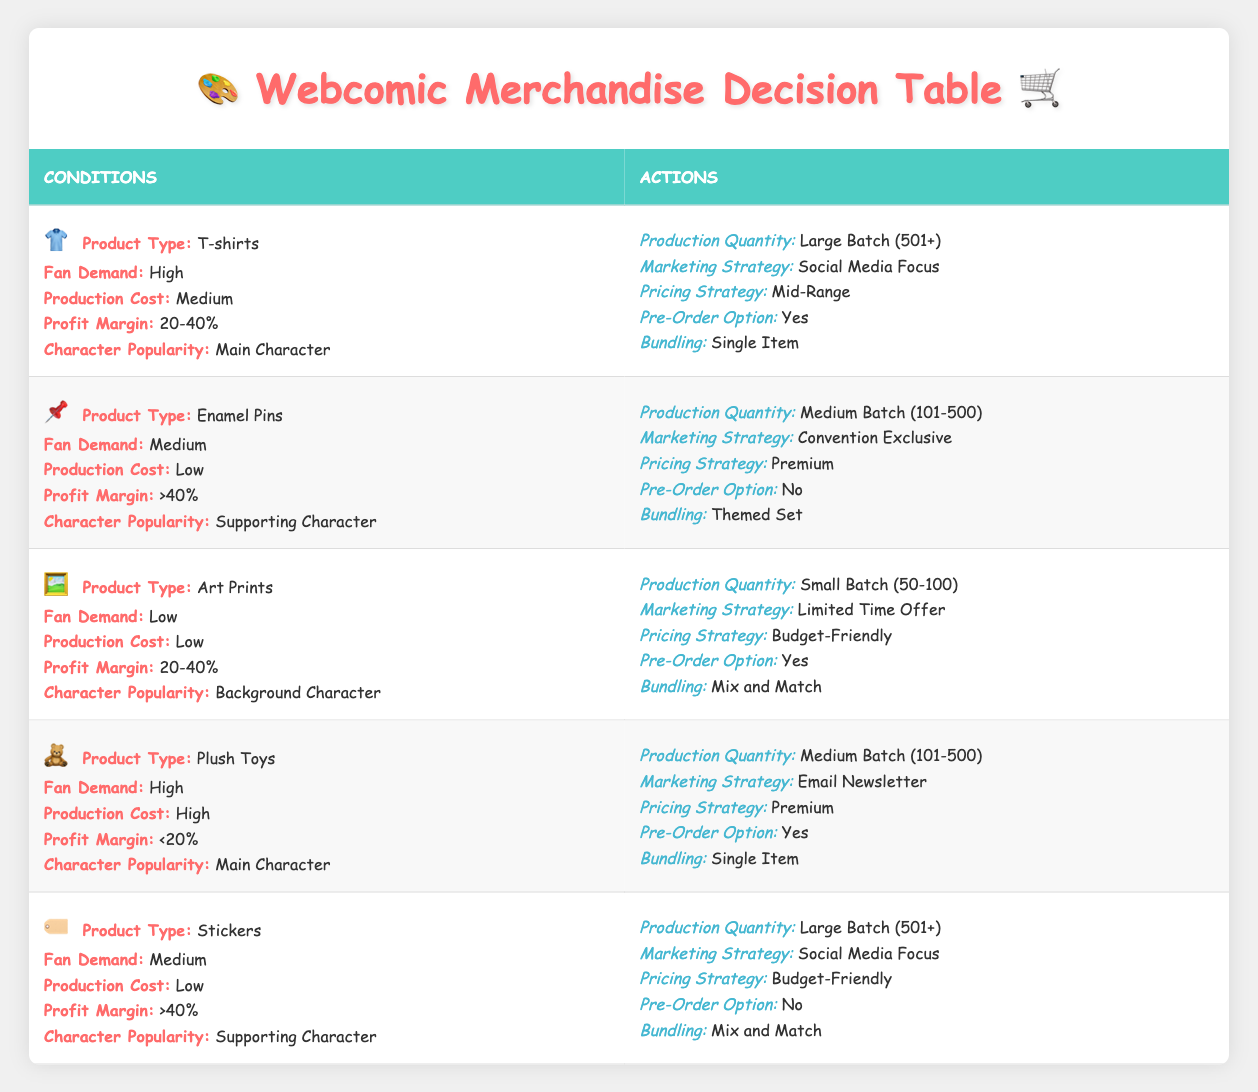What is the production quantity for T-shirts with high fan demand? The table states that for T-shirts with high fan demand, the production quantity is categorized as "Large Batch (501+)". This information can be found by looking at the row corresponding to T-shirts under the conditions of high fan demand.
Answer: Large Batch (501+) What marketing strategy is recommended for stickers with medium fan demand? According to the table, stickers with medium fan demand are advised to use a "Social Media Focus" marketing strategy. This is found under the actions section for the row that discusses stickers.
Answer: Social Media Focus Is there a pre-order option for Enamel Pins with medium fan demand? The table shows that for Enamel Pins with medium fan demand, the pre-order option is "No". This is specified directly in the actions section of the relevant row.
Answer: No What is the profit margin for Art Prints targeted at background characters? The table indicates that the profit margin for Art Prints, when the character's popularity is a background character, falls within the range of "20-40%". This can be seen in the corresponding row for Art Prints.
Answer: 20-40% For products with high fan demand and medium production cost, which type of products can be produced in large batches? The only product that meets the criteria of high fan demand and medium production cost, which can be produced in large batches, is T-shirts as indicated in the table. Other product types either do not have medium production costs or do not have high fan demand.
Answer: T-shirts What percentage of profit margin is associated with Plush Toys and is there a pre-order option? The table specifies that Plush Toys have a profit margin of "<20%" and do have a pre-order option listed as "Yes". To determine this, one needs to refer to the row regarding plush toys and identify these actions and conditions together.
Answer: <20%, Yes How many products are suggested to have a "Limited Time Offer" marketing strategy? Looking at the table, only Art Prints are associated with a "Limited Time Offer" marketing strategy. Checking each row helps confirm that no other products recommend this strategy. Thus, the answer is based on a count of the rows.
Answer: 1 Which product has the highest production quantity for a supporting character? When looking at the products for supporting characters, the "Stickers" have the highest production quantity listed as "Large Batch (501+)" compared to Enamel Pins, which have a medium batch. This requires comparing the actions listed for each matching product.
Answer: Stickers What products have a "Premium" pricing strategy and what is their character popularity? The table shows two products with a premium pricing strategy: "Enamel Pins" (Supporting Character) and "Plush Toys" (Main Character). To arrive at the answer, one must find all products labeled with a premium pricing strategy and note their respective character popularity.
Answer: Enamel Pins (Supporting Character), Plush Toys (Main Character) 